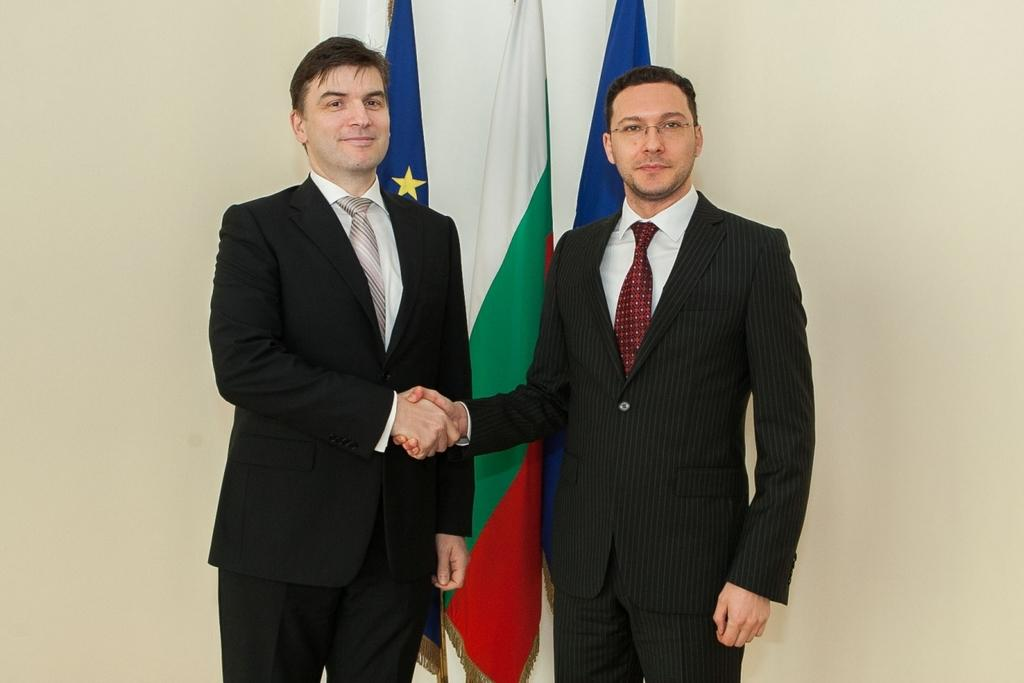How many people are in the image? There are two men in the image. What are the men doing in the image? The men are greeting each other. What can be seen in the background of the image? There are three flags and a wall in the background. What type of club is being used by the men in the image? There is no club present in the image; the men are simply greeting each other. 